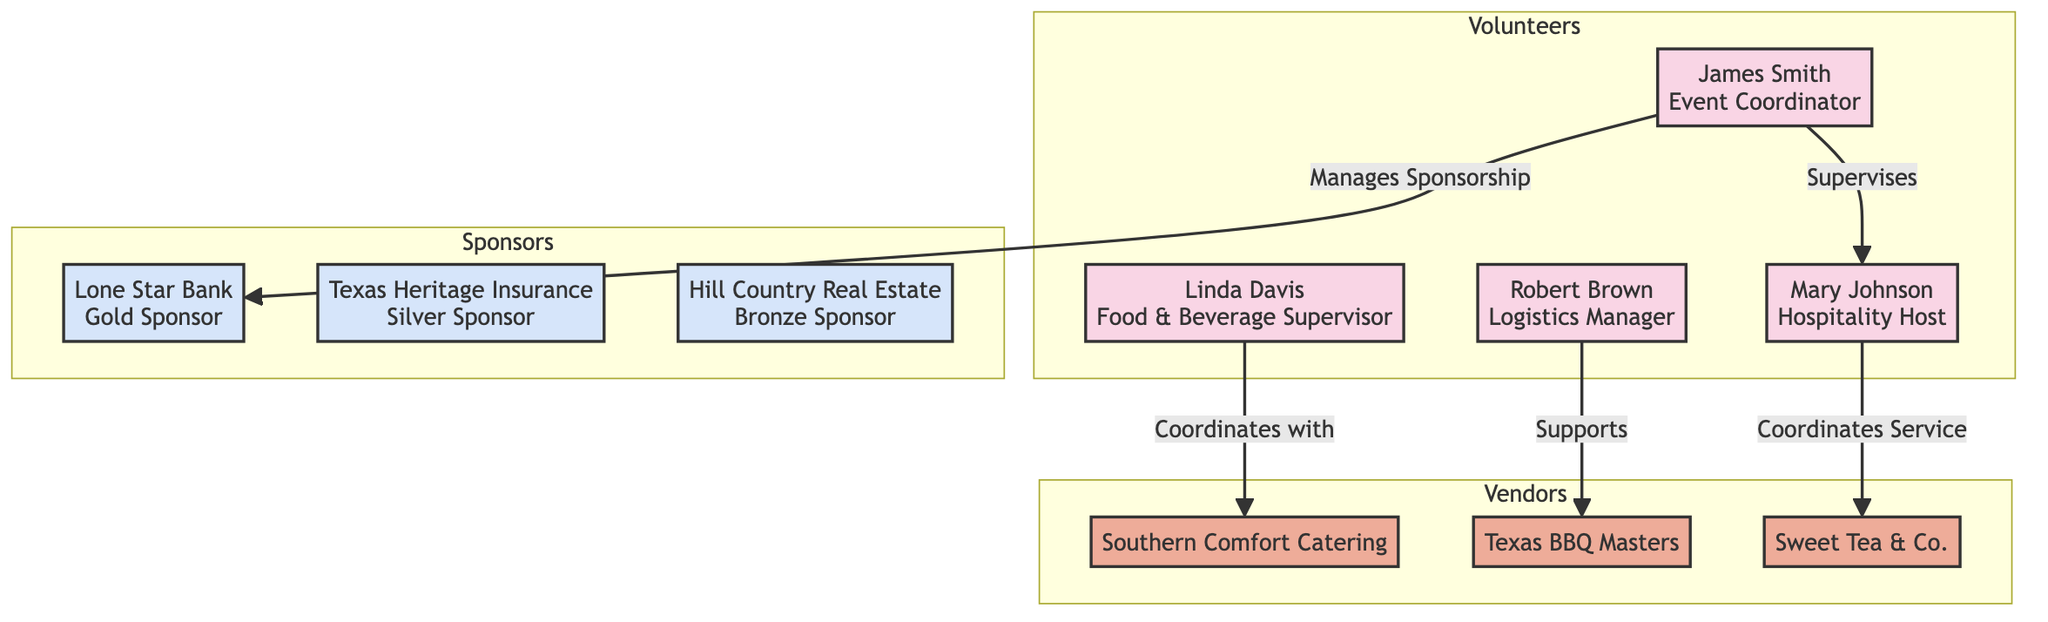What is the role of James Smith? In the diagram, James Smith is labeled as the "Event Coordinator," which is clearly indicated next to his name in the volunteer section.
Answer: Event Coordinator How many volunteers are listed in the diagram? To find the count of volunteers, we review the volunteer section, which includes four individuals: James Smith, Mary Johnson, Robert Brown, and Linda Davis. Therefore, the total is four volunteers.
Answer: 4 Who coordinates with Southern Comfort Catering? Looking at the interconnections, Linda Davis is indicated to "Coordinate with" Southern Comfort Catering, highlighting her responsibility in the connections.
Answer: Linda Davis What type of support does Robert Brown provide to Texas BBQ Masters? The diagram notes that Robert Brown "Supports" Texas BBQ Masters, referring to the assistance he provides in the logistical aspects as shown in the interconnections.
Answer: Support Which sponsor has the highest financial contribution? According to the roles outlined in the sponsors section, Lone Star Bank is listed as the "Gold Sponsor," typically indicating the highest level of sponsorship compared to the Silver and Bronze sponsors mentioned.
Answer: Gold Sponsor How many vendors are represented in the diagram? In the vendor section, there are three entities listed: Southern Comfort Catering, Texas BBQ Masters, and Sweet Tea & Co., resulting in a total of three vendors.
Answer: 3 What is Mary Johnson’s responsibility regarding guests? The responsibilities for Mary Johnson include "Greeting guests," which is explicitly detailed in her role as Hospitality Host in the volunteer section of the diagram.
Answer: Greeting guests Which volunteer manages the Gold Sponsorship? A review of the interconnections shows that James Smith is responsible for managing the sponsorship with Lone Star Bank, which identifies him as the volunteer in charge of the Gold Sponsorship.
Answer: James Smith What is the nature of the relationship between Linda Davis and Southern Comfort Catering? The interconnection specifies that Linda Davis "Coordinates with" Southern Comfort Catering, indicating a collaborative relationship aimed at managing food services.
Answer: Coordination 